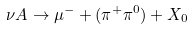Convert formula to latex. <formula><loc_0><loc_0><loc_500><loc_500>\nu A \rightarrow { \mu ^ { - } } + ( { \pi ^ { + } } { \pi ^ { 0 } ) } + X _ { 0 }</formula> 